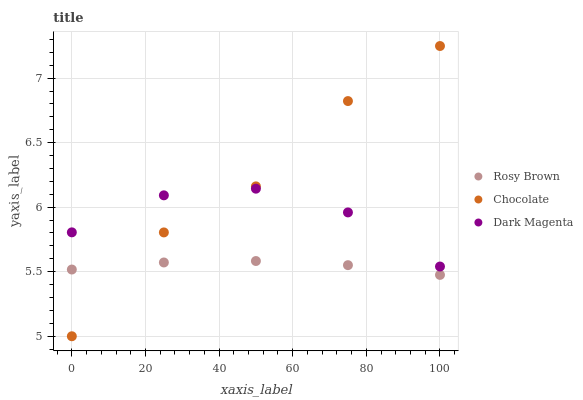Does Rosy Brown have the minimum area under the curve?
Answer yes or no. Yes. Does Chocolate have the maximum area under the curve?
Answer yes or no. Yes. Does Dark Magenta have the minimum area under the curve?
Answer yes or no. No. Does Dark Magenta have the maximum area under the curve?
Answer yes or no. No. Is Rosy Brown the smoothest?
Answer yes or no. Yes. Is Chocolate the roughest?
Answer yes or no. Yes. Is Dark Magenta the smoothest?
Answer yes or no. No. Is Dark Magenta the roughest?
Answer yes or no. No. Does Chocolate have the lowest value?
Answer yes or no. Yes. Does Dark Magenta have the lowest value?
Answer yes or no. No. Does Chocolate have the highest value?
Answer yes or no. Yes. Does Dark Magenta have the highest value?
Answer yes or no. No. Is Rosy Brown less than Dark Magenta?
Answer yes or no. Yes. Is Dark Magenta greater than Rosy Brown?
Answer yes or no. Yes. Does Chocolate intersect Dark Magenta?
Answer yes or no. Yes. Is Chocolate less than Dark Magenta?
Answer yes or no. No. Is Chocolate greater than Dark Magenta?
Answer yes or no. No. Does Rosy Brown intersect Dark Magenta?
Answer yes or no. No. 